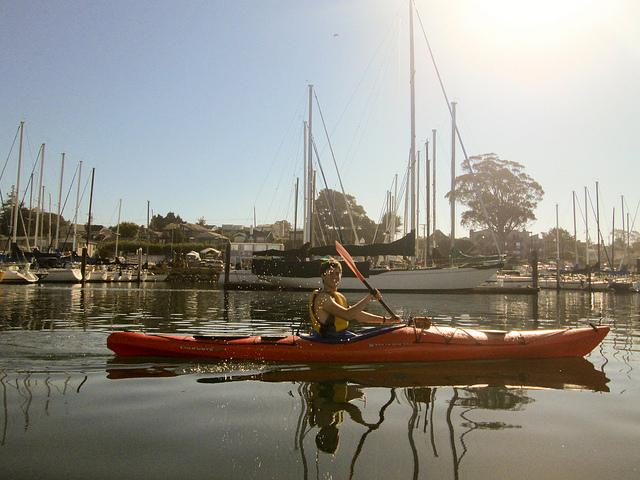What is the person riding in?

Choices:
A) airplane
B) sled
C) helicopter
D) canoe canoe 